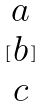<formula> <loc_0><loc_0><loc_500><loc_500>[ \begin{matrix} a \\ b \\ c \end{matrix} ]</formula> 